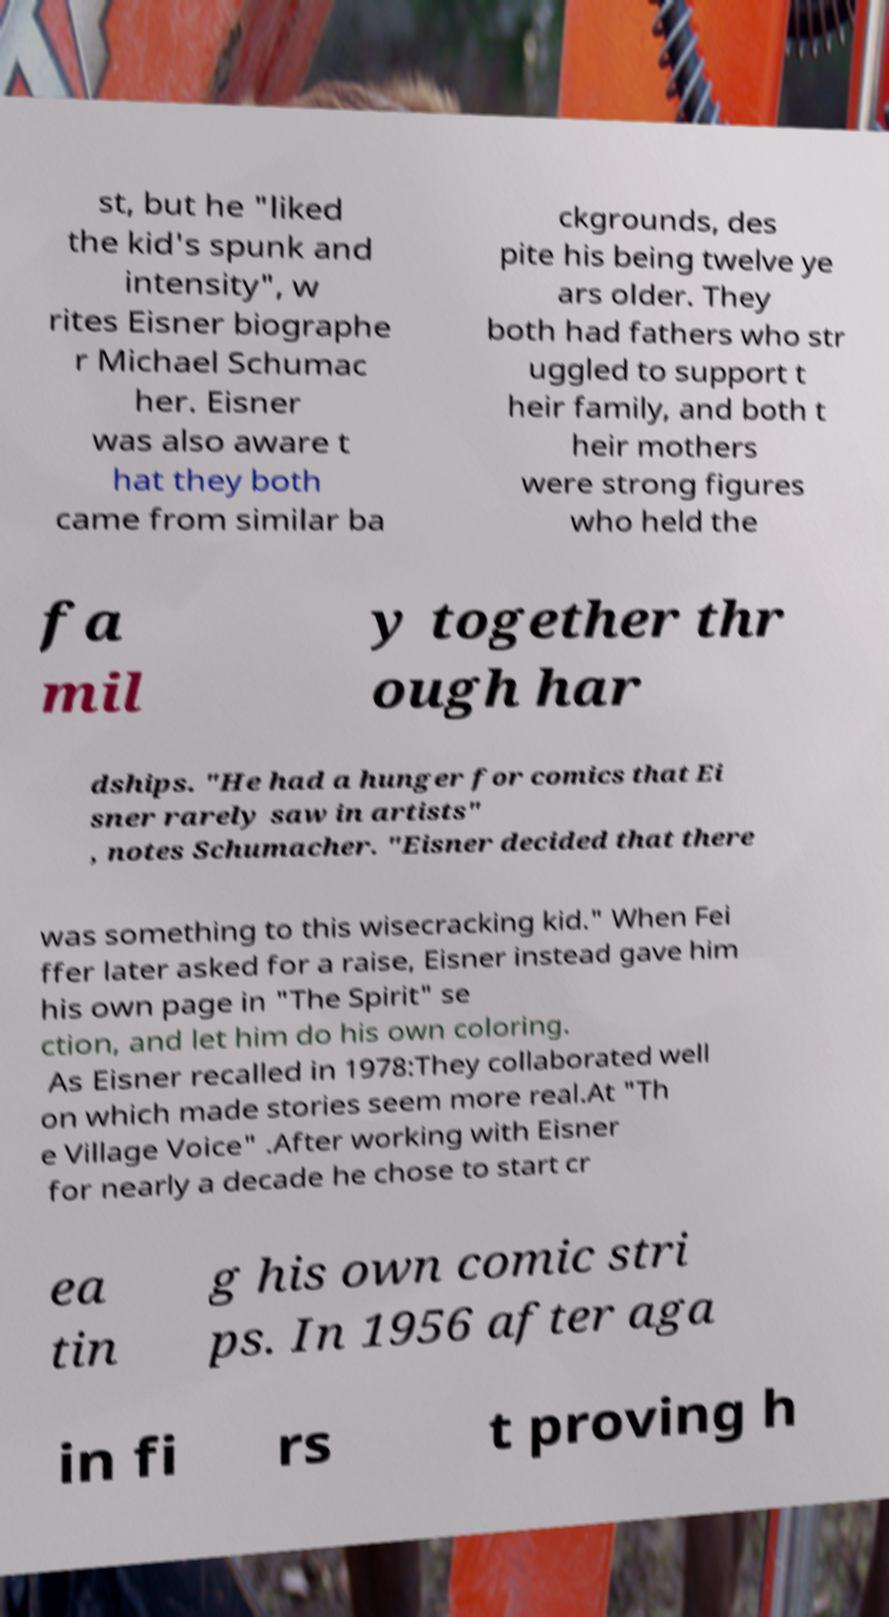Can you accurately transcribe the text from the provided image for me? st, but he "liked the kid's spunk and intensity", w rites Eisner biographe r Michael Schumac her. Eisner was also aware t hat they both came from similar ba ckgrounds, des pite his being twelve ye ars older. They both had fathers who str uggled to support t heir family, and both t heir mothers were strong figures who held the fa mil y together thr ough har dships. "He had a hunger for comics that Ei sner rarely saw in artists" , notes Schumacher. "Eisner decided that there was something to this wisecracking kid." When Fei ffer later asked for a raise, Eisner instead gave him his own page in "The Spirit" se ction, and let him do his own coloring. As Eisner recalled in 1978:They collaborated well on which made stories seem more real.At "Th e Village Voice" .After working with Eisner for nearly a decade he chose to start cr ea tin g his own comic stri ps. In 1956 after aga in fi rs t proving h 